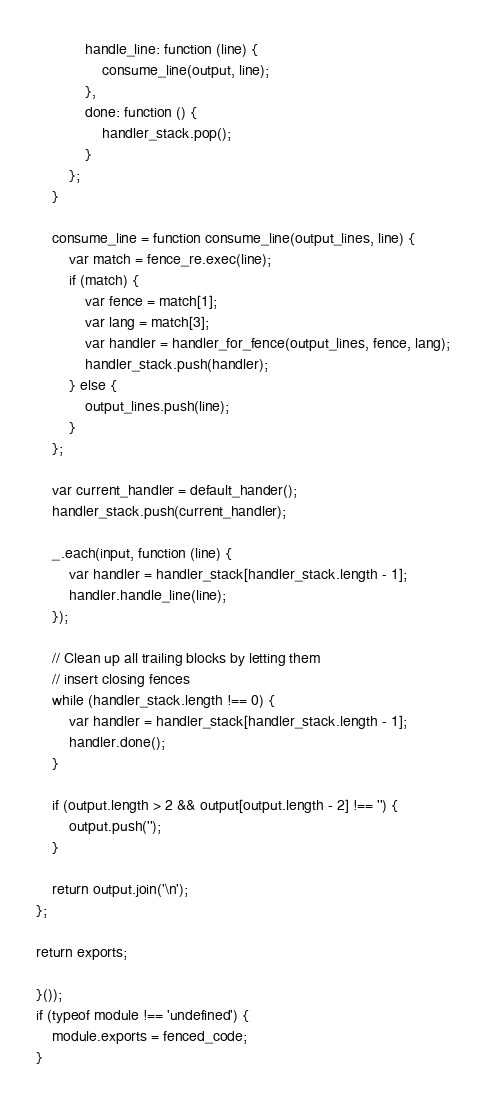<code> <loc_0><loc_0><loc_500><loc_500><_JavaScript_>            handle_line: function (line) {
                consume_line(output, line);
            },
            done: function () {
                handler_stack.pop();
            }
        };
    }

    consume_line = function consume_line(output_lines, line) {
        var match = fence_re.exec(line);
        if (match) {
            var fence = match[1];
            var lang = match[3];
            var handler = handler_for_fence(output_lines, fence, lang);
            handler_stack.push(handler);
        } else {
            output_lines.push(line);
        }
    };

    var current_handler = default_hander();
    handler_stack.push(current_handler);

    _.each(input, function (line) {
        var handler = handler_stack[handler_stack.length - 1];
        handler.handle_line(line);
    });

    // Clean up all trailing blocks by letting them
    // insert closing fences
    while (handler_stack.length !== 0) {
        var handler = handler_stack[handler_stack.length - 1];
        handler.done();
    }

    if (output.length > 2 && output[output.length - 2] !== '') {
        output.push('');
    }

    return output.join('\n');
};

return exports;

}());
if (typeof module !== 'undefined') {
    module.exports = fenced_code;
}
</code> 